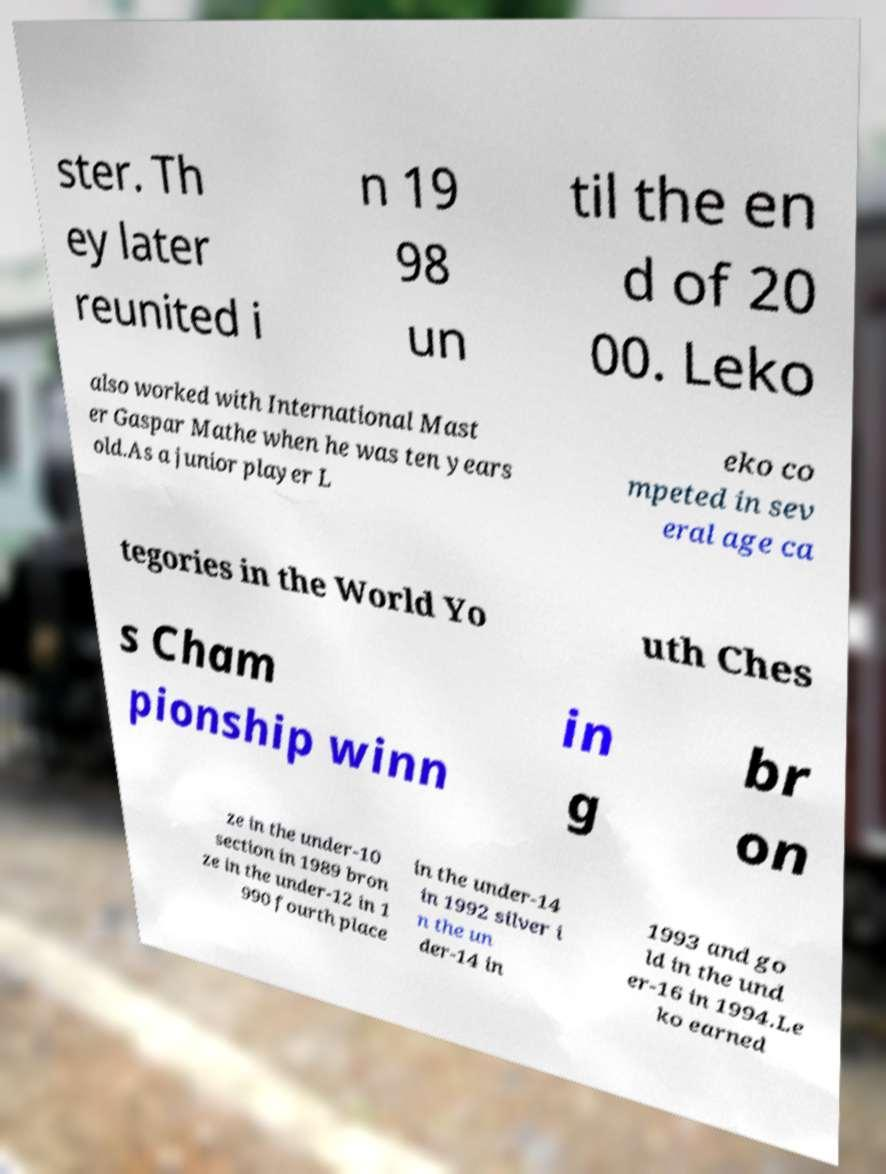Please read and relay the text visible in this image. What does it say? ster. Th ey later reunited i n 19 98 un til the en d of 20 00. Leko also worked with International Mast er Gaspar Mathe when he was ten years old.As a junior player L eko co mpeted in sev eral age ca tegories in the World Yo uth Ches s Cham pionship winn in g br on ze in the under-10 section in 1989 bron ze in the under-12 in 1 990 fourth place in the under-14 in 1992 silver i n the un der-14 in 1993 and go ld in the und er-16 in 1994.Le ko earned 